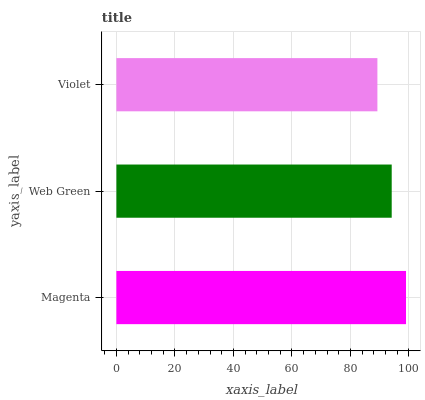Is Violet the minimum?
Answer yes or no. Yes. Is Magenta the maximum?
Answer yes or no. Yes. Is Web Green the minimum?
Answer yes or no. No. Is Web Green the maximum?
Answer yes or no. No. Is Magenta greater than Web Green?
Answer yes or no. Yes. Is Web Green less than Magenta?
Answer yes or no. Yes. Is Web Green greater than Magenta?
Answer yes or no. No. Is Magenta less than Web Green?
Answer yes or no. No. Is Web Green the high median?
Answer yes or no. Yes. Is Web Green the low median?
Answer yes or no. Yes. Is Violet the high median?
Answer yes or no. No. Is Violet the low median?
Answer yes or no. No. 